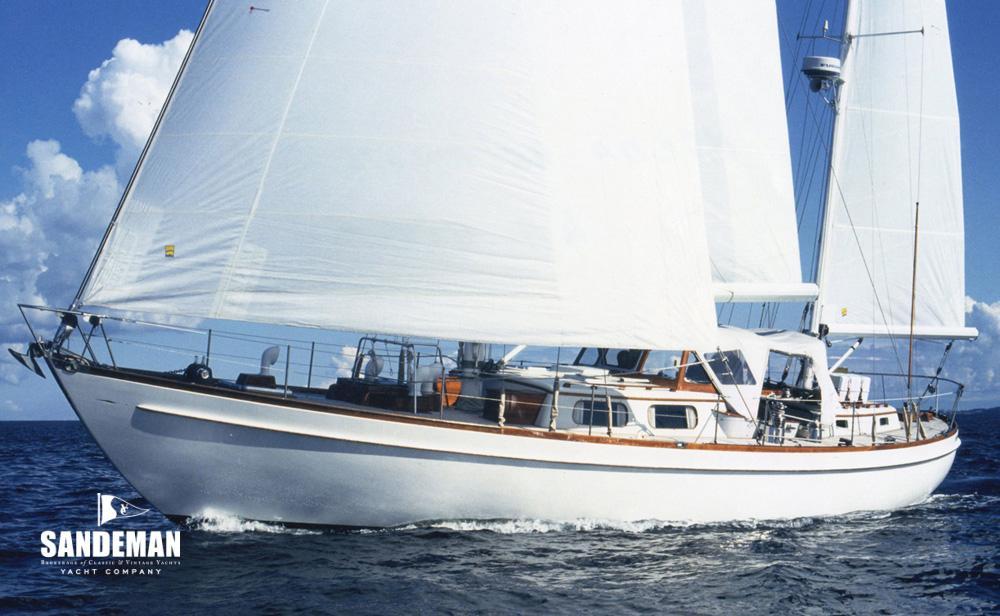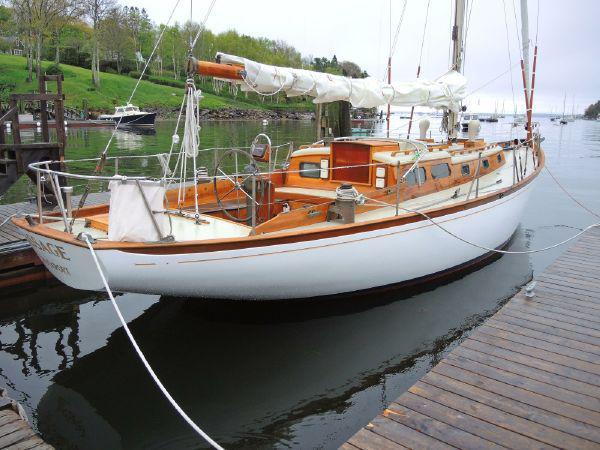The first image is the image on the left, the second image is the image on the right. Evaluate the accuracy of this statement regarding the images: "A boat is tied up to a dock.". Is it true? Answer yes or no. Yes. The first image is the image on the left, the second image is the image on the right. For the images displayed, is the sentence "The left and right image contains a total of two sailboats in the water." factually correct? Answer yes or no. Yes. 